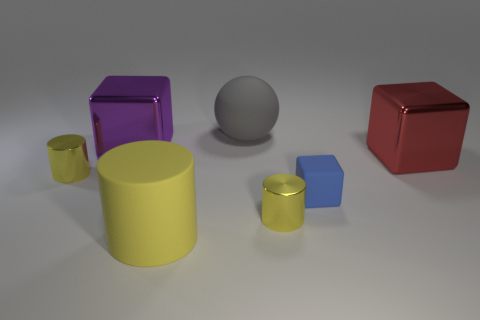Subtract all large yellow matte cylinders. How many cylinders are left? 2 Add 1 matte spheres. How many objects exist? 8 Subtract all cylinders. How many objects are left? 4 Subtract all brown cubes. Subtract all yellow balls. How many cubes are left? 3 Subtract all red blocks. Subtract all red shiny objects. How many objects are left? 5 Add 6 small blue things. How many small blue things are left? 7 Add 3 large rubber cylinders. How many large rubber cylinders exist? 4 Subtract 0 green balls. How many objects are left? 7 